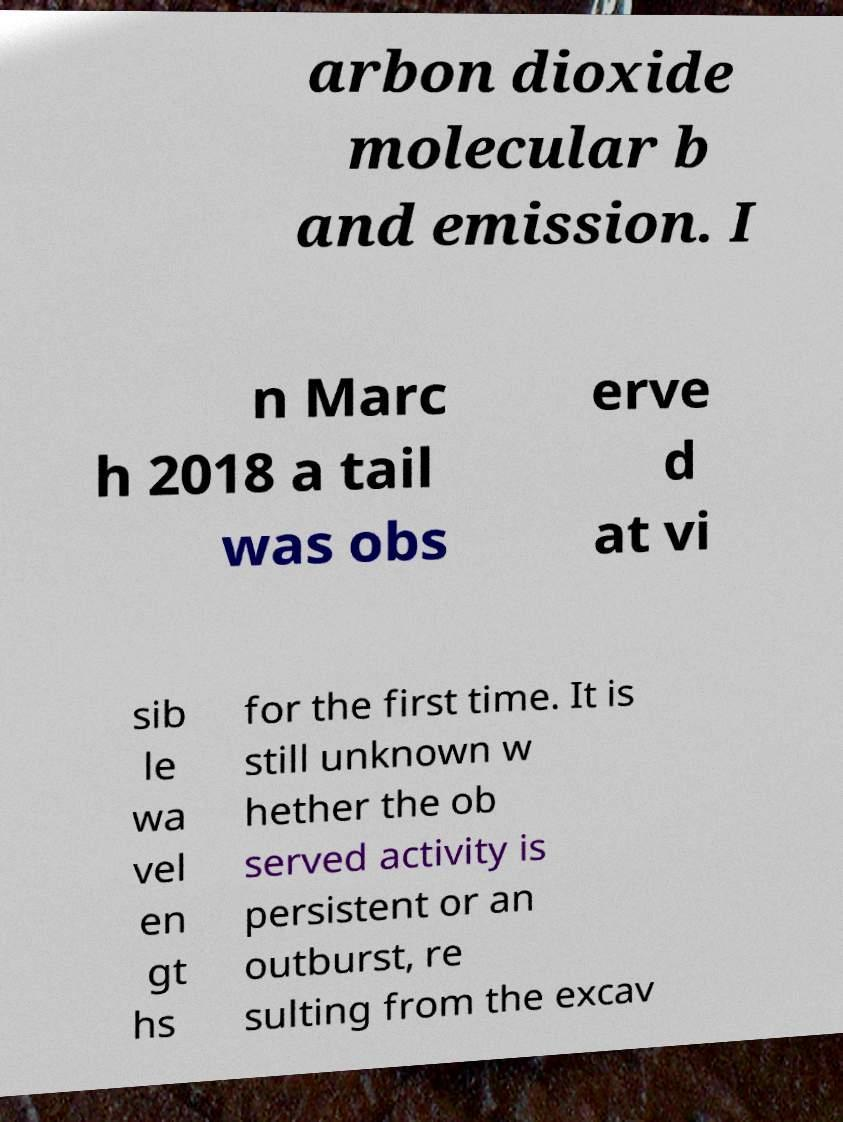Could you assist in decoding the text presented in this image and type it out clearly? arbon dioxide molecular b and emission. I n Marc h 2018 a tail was obs erve d at vi sib le wa vel en gt hs for the first time. It is still unknown w hether the ob served activity is persistent or an outburst, re sulting from the excav 